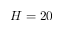Convert formula to latex. <formula><loc_0><loc_0><loc_500><loc_500>H = 2 0</formula> 